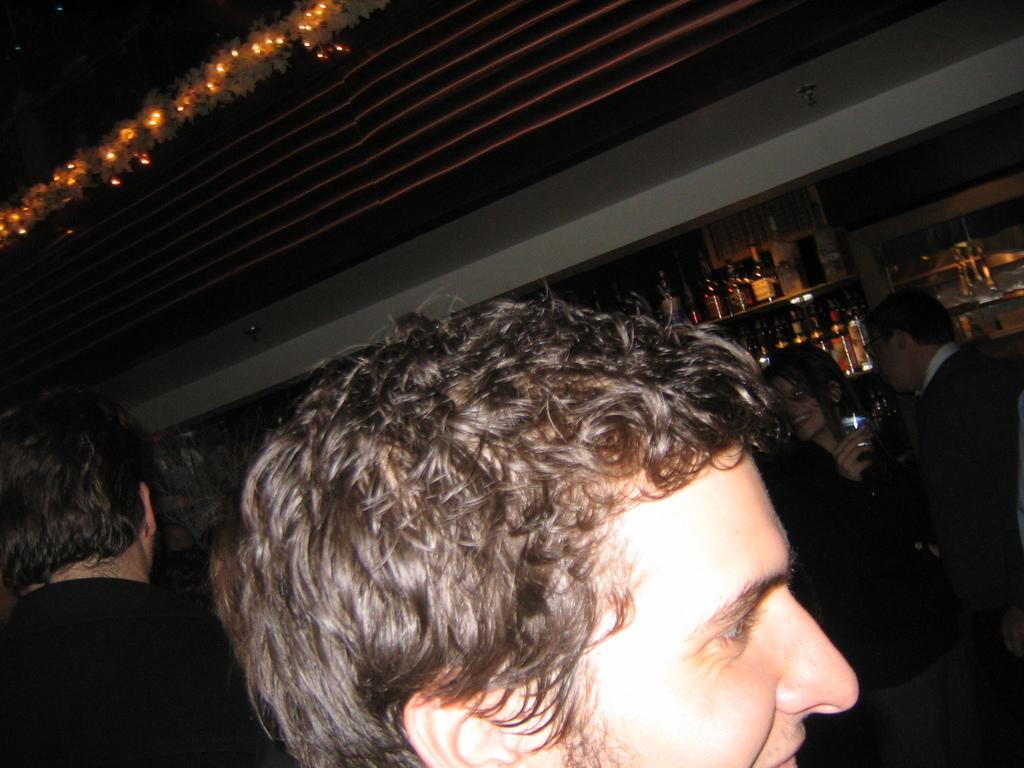Can you describe this image briefly? In the image there is a man in the foreground and behind him there are some other people, in the background there are many alcohol bottles kept on the shelves. 